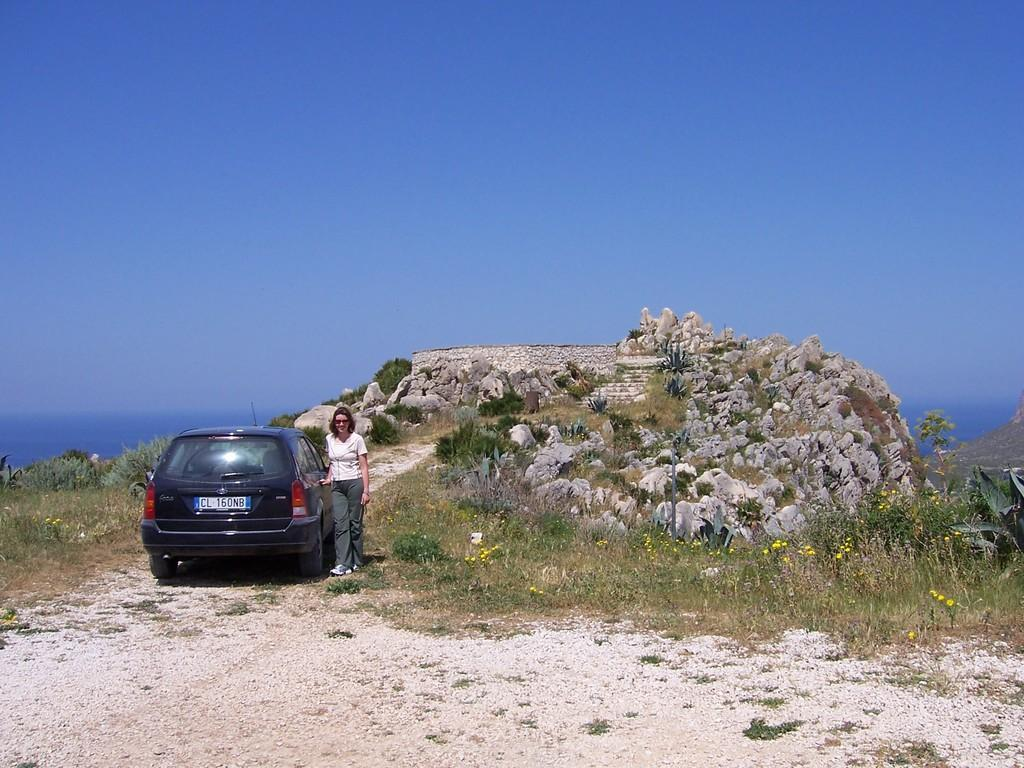What is the person in the image doing? The person is standing beside a car in the image. What can be seen in the background of the image? There are rocks, trees, and the sky visible in the background of the image. Can you see a kitten tying a knot around a cracker in the image? No, there is no kitten or cracker present in the image. 